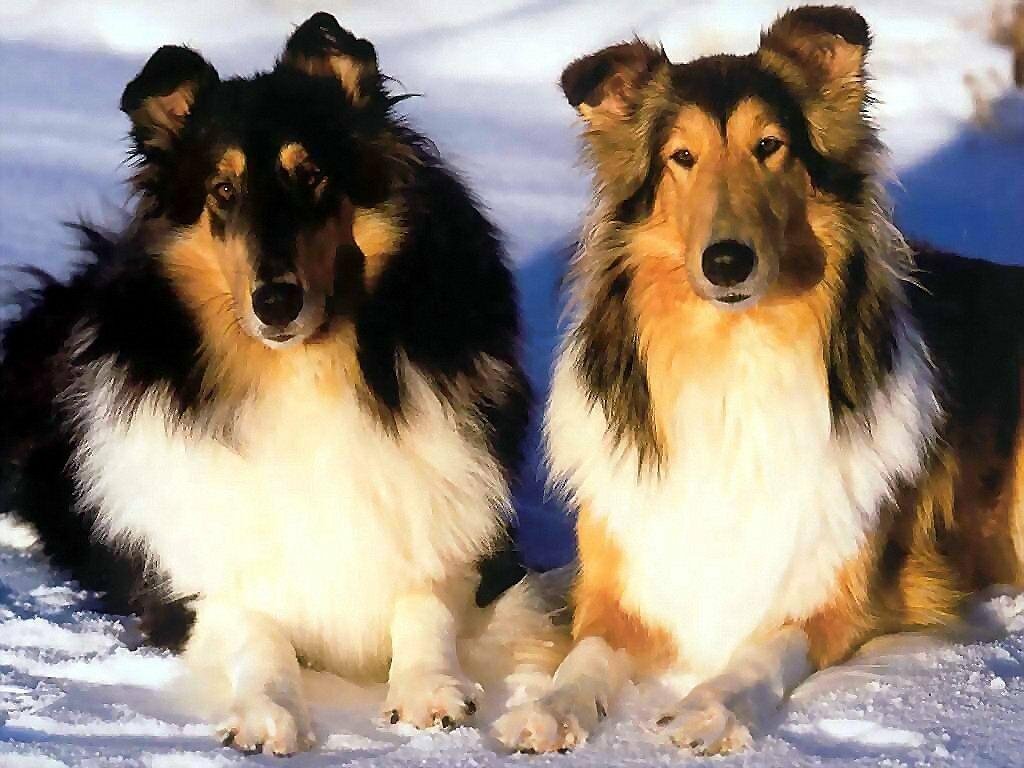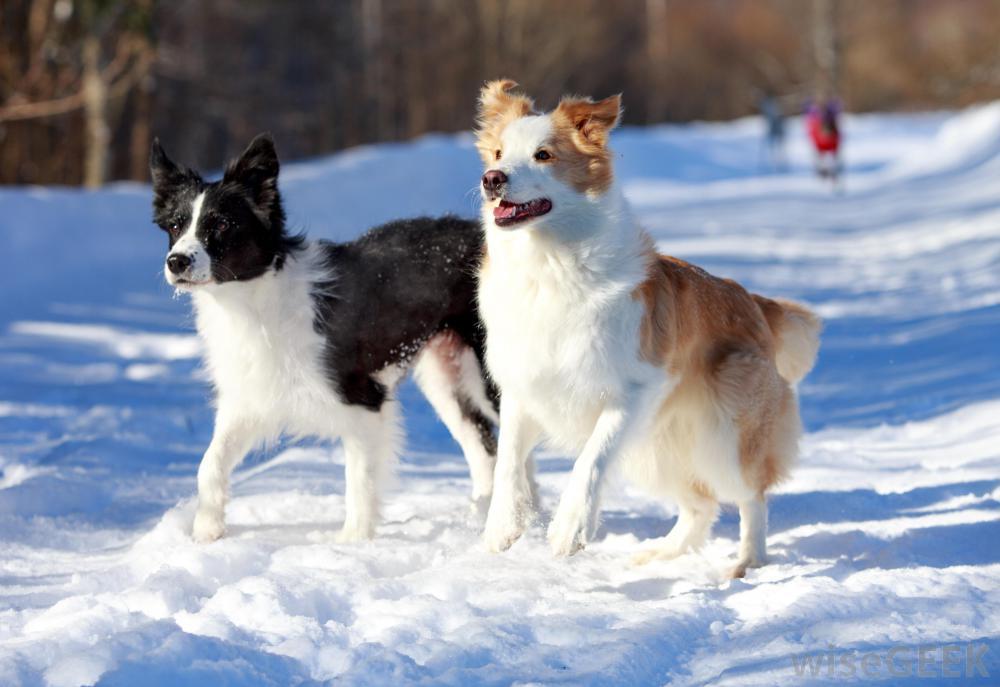The first image is the image on the left, the second image is the image on the right. Examine the images to the left and right. Is the description "There are at most three dogs." accurate? Answer yes or no. No. The first image is the image on the left, the second image is the image on the right. Considering the images on both sides, is "There are no more than three dogs." valid? Answer yes or no. No. 